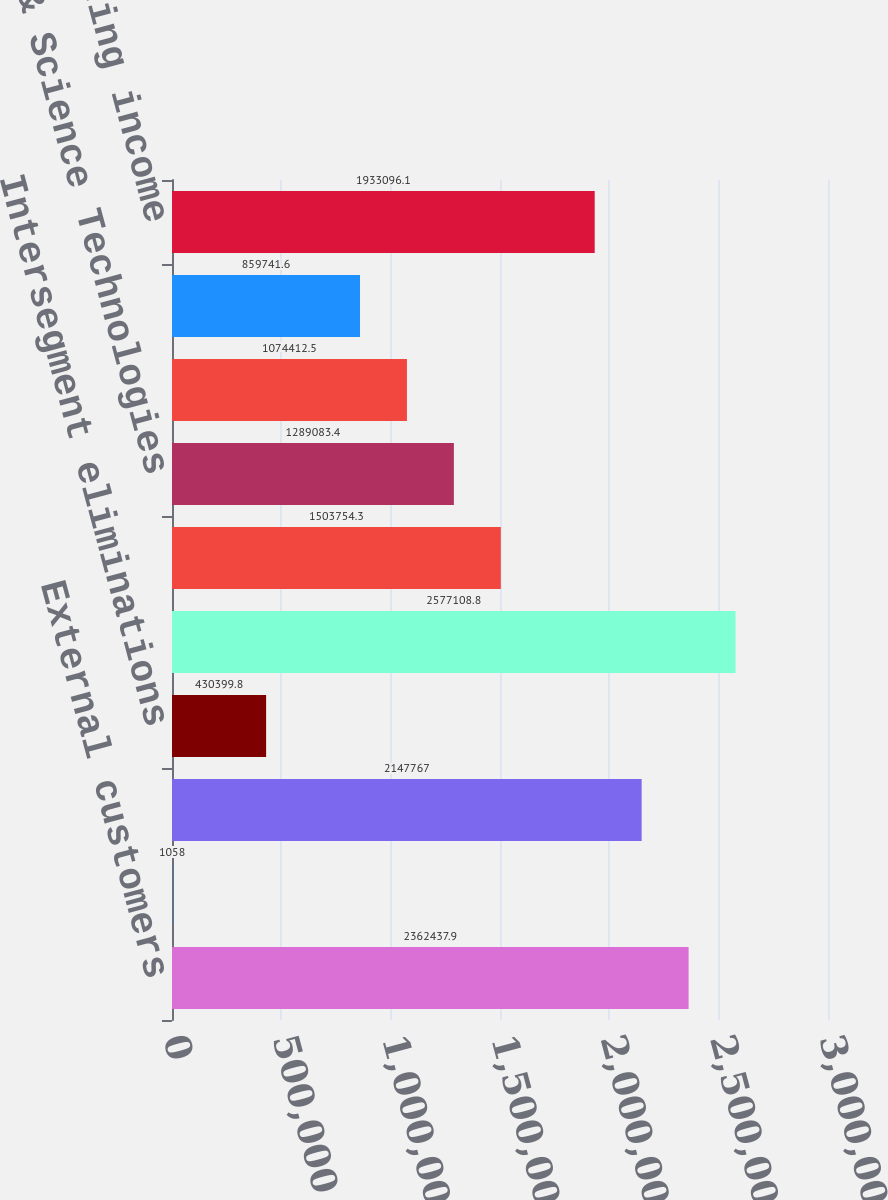Convert chart. <chart><loc_0><loc_0><loc_500><loc_500><bar_chart><fcel>External customers<fcel>Intersegment sales<fcel>Total segment sales<fcel>Intersegment eliminations<fcel>Total net sales<fcel>Fluid & Metering Technologies<fcel>Health & Science Technologies<fcel>Fire & Safety/Diversified<fcel>Corporate office<fcel>Total operating income<nl><fcel>2.36244e+06<fcel>1058<fcel>2.14777e+06<fcel>430400<fcel>2.57711e+06<fcel>1.50375e+06<fcel>1.28908e+06<fcel>1.07441e+06<fcel>859742<fcel>1.9331e+06<nl></chart> 